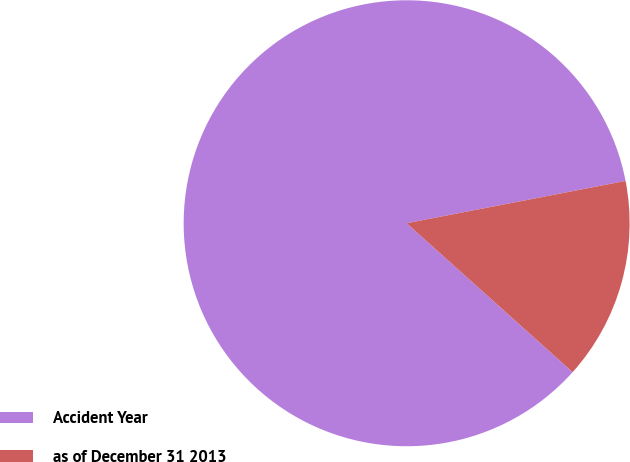<chart> <loc_0><loc_0><loc_500><loc_500><pie_chart><fcel>Accident Year<fcel>as of December 31 2013<nl><fcel>85.32%<fcel>14.68%<nl></chart> 